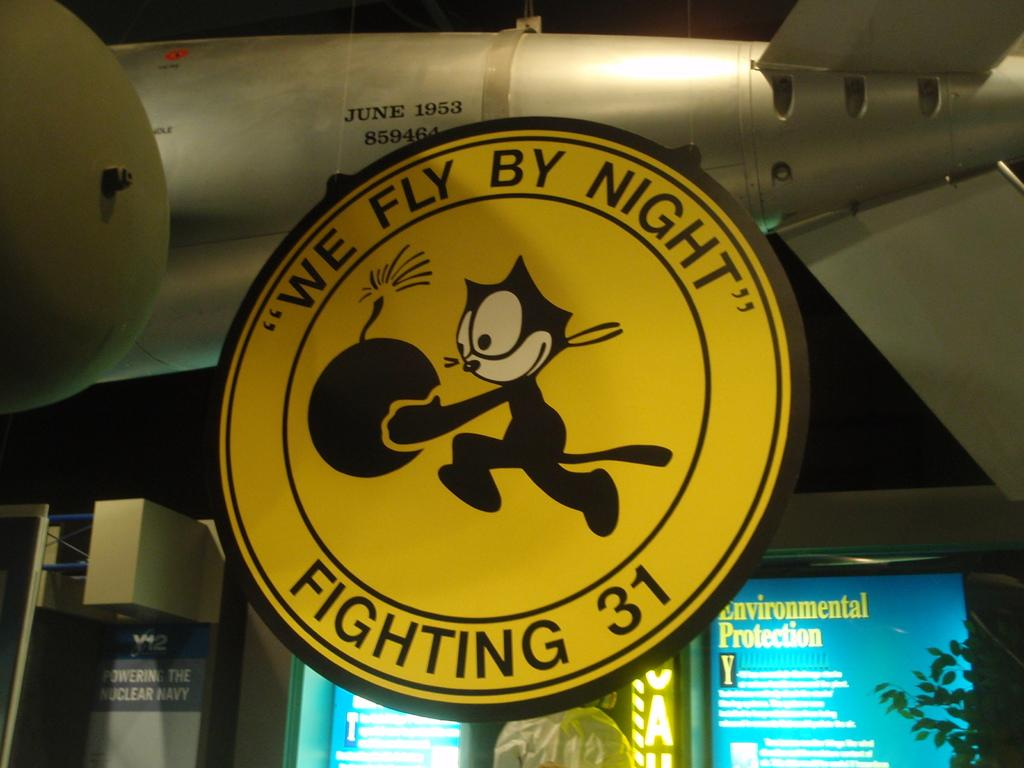<image>
Share a concise interpretation of the image provided. The circular yellow logo features a black cat carrying a bomb and the motto "We Fly By Night". 